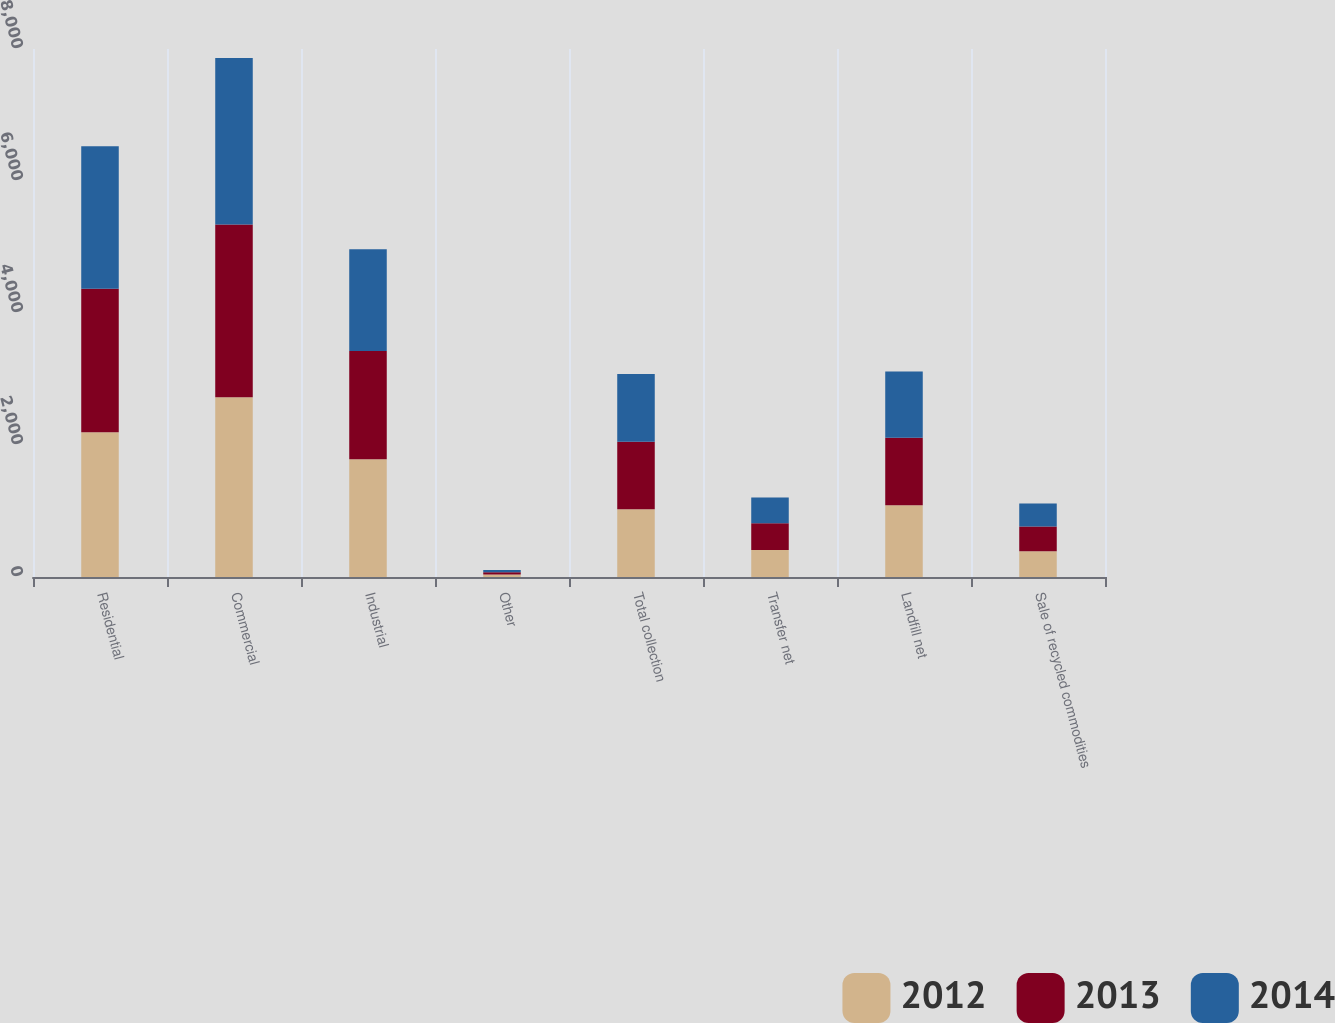<chart> <loc_0><loc_0><loc_500><loc_500><stacked_bar_chart><ecel><fcel>Residential<fcel>Commercial<fcel>Industrial<fcel>Other<fcel>Total collection<fcel>Transfer net<fcel>Landfill net<fcel>Sale of recycled commodities<nl><fcel>2012<fcel>2193.6<fcel>2723.3<fcel>1784<fcel>37.2<fcel>1025<fcel>408.2<fcel>1086.4<fcel>390.8<nl><fcel>2013<fcel>2175.5<fcel>2616.9<fcel>1639.4<fcel>34.7<fcel>1025<fcel>406.6<fcel>1025<fcel>374.6<nl><fcel>2014<fcel>2155.7<fcel>2523.2<fcel>1544.2<fcel>33.4<fcel>1025<fcel>389.2<fcel>1000.8<fcel>349<nl></chart> 